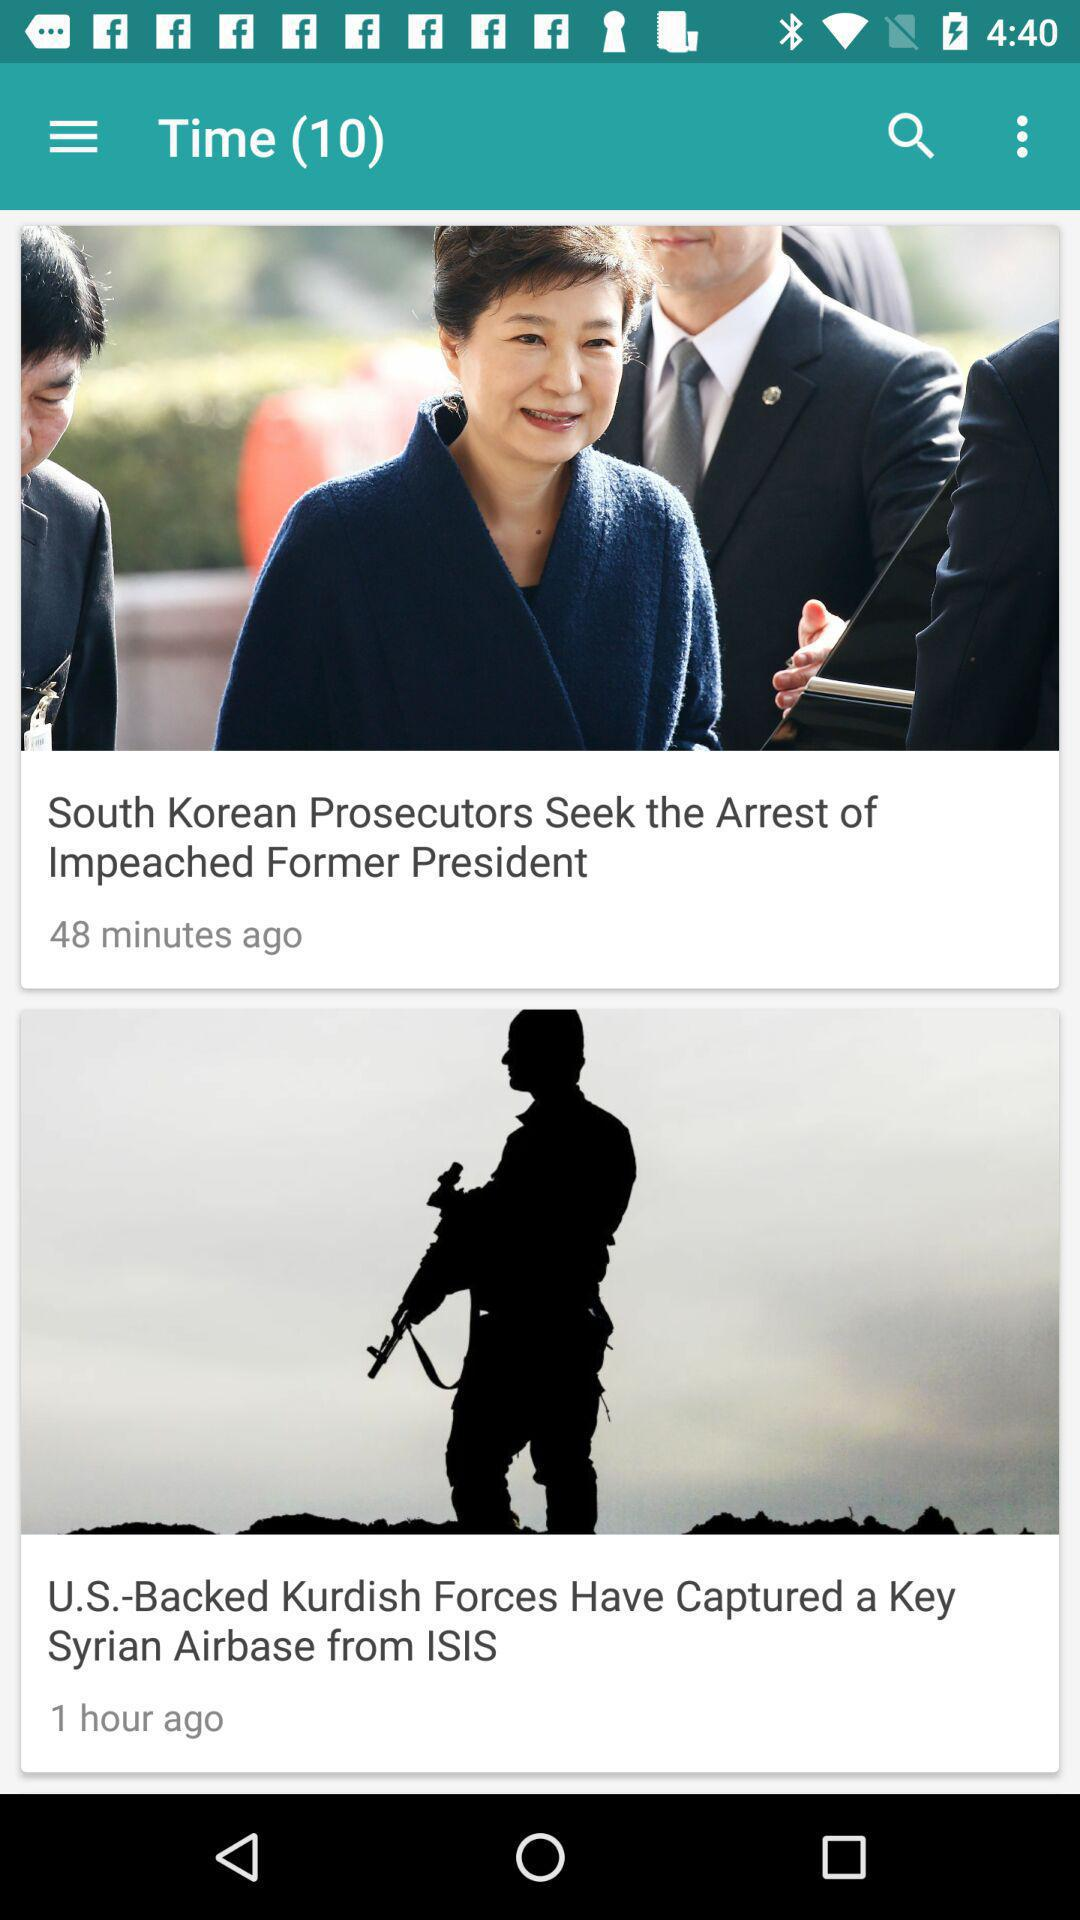When was the article "South Korean Prosecutors Seek the Arrest of Impeached Former President" published? It was published 48 minutes ago. 